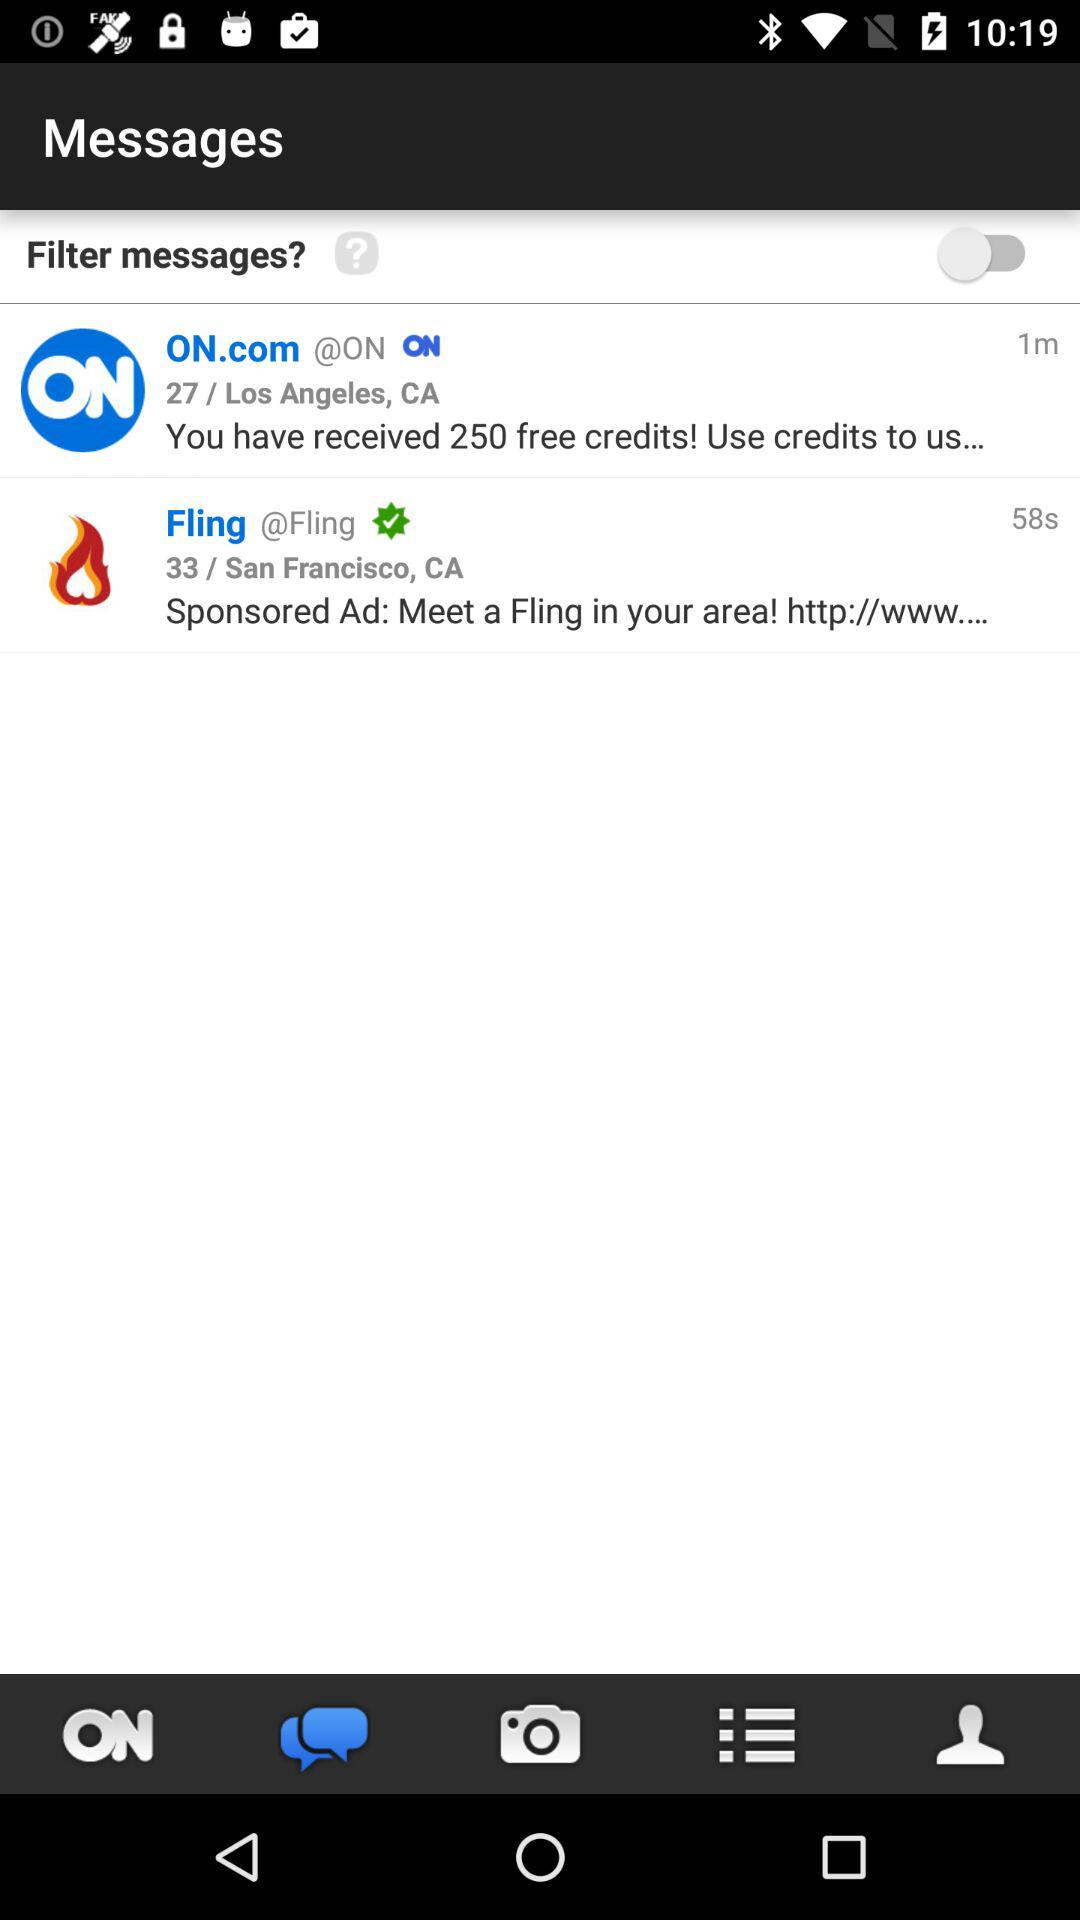When was the message "ON.com" delivered? The message was delivered 1 minute ago. 